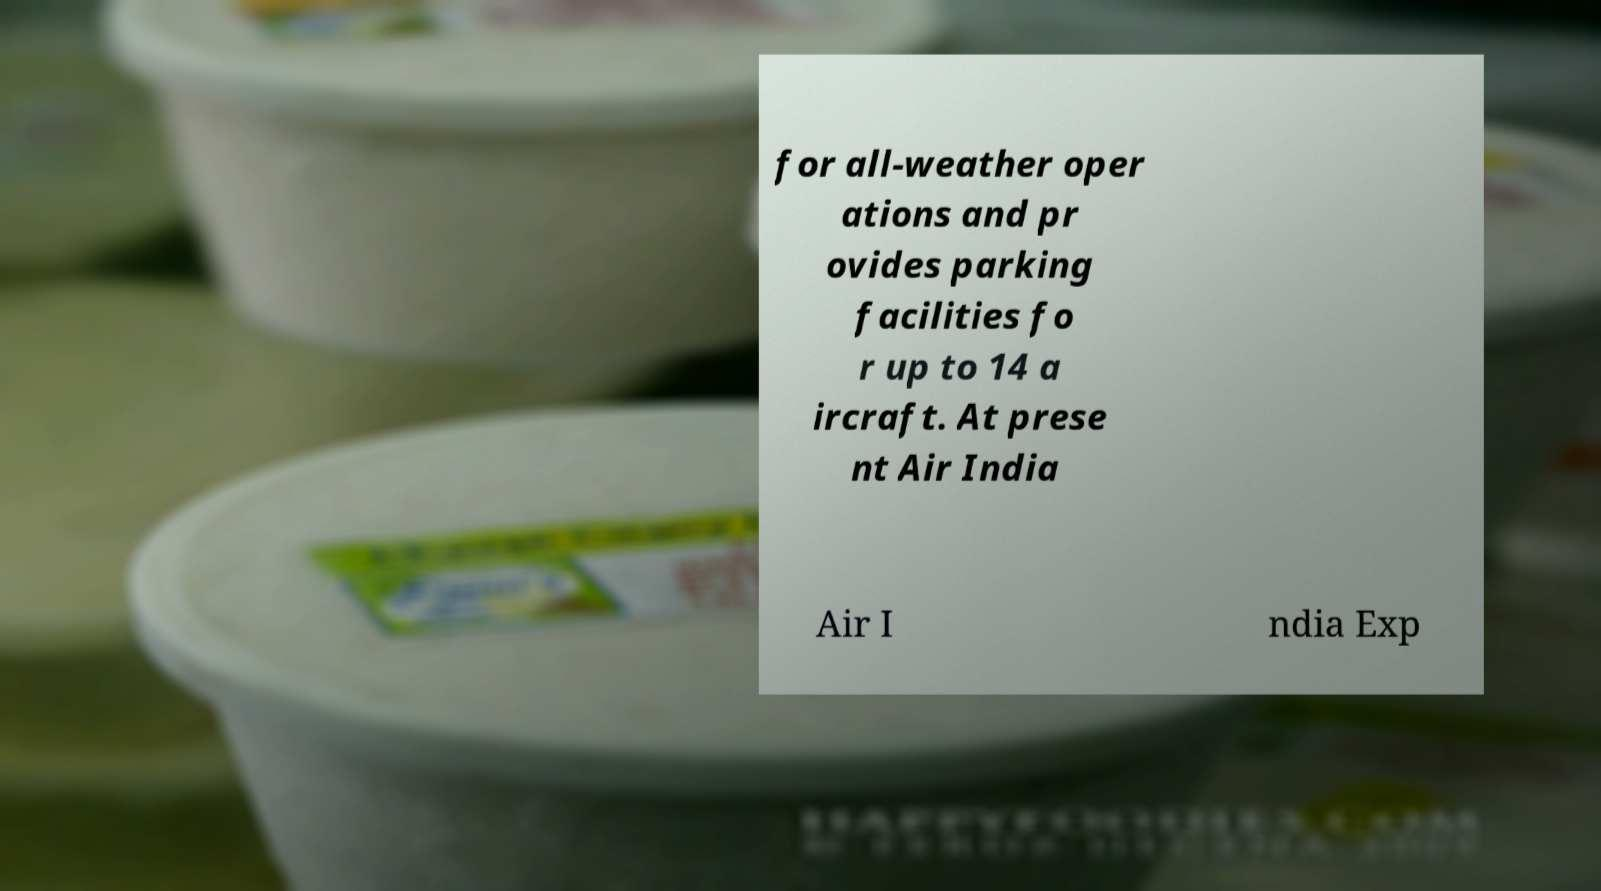What messages or text are displayed in this image? I need them in a readable, typed format. for all-weather oper ations and pr ovides parking facilities fo r up to 14 a ircraft. At prese nt Air India Air I ndia Exp 